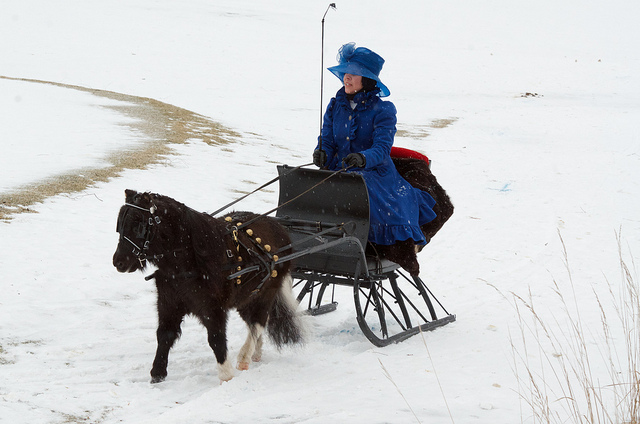How many people are riding on this sled? There is one person riding on the sled, dressed in a striking blue outfit which contrasts with the white snowy landscape. 